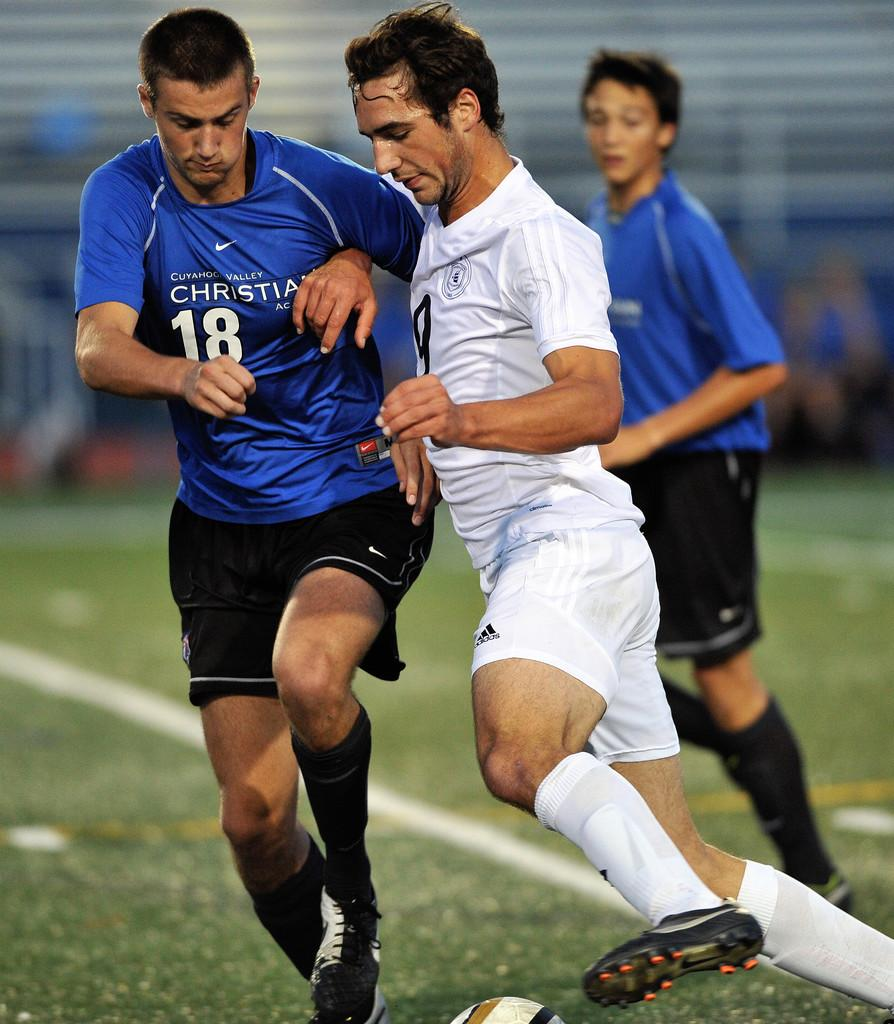Provide a one-sentence caption for the provided image. Cuyahoga Valley has a soccer team with blue uniforms. 